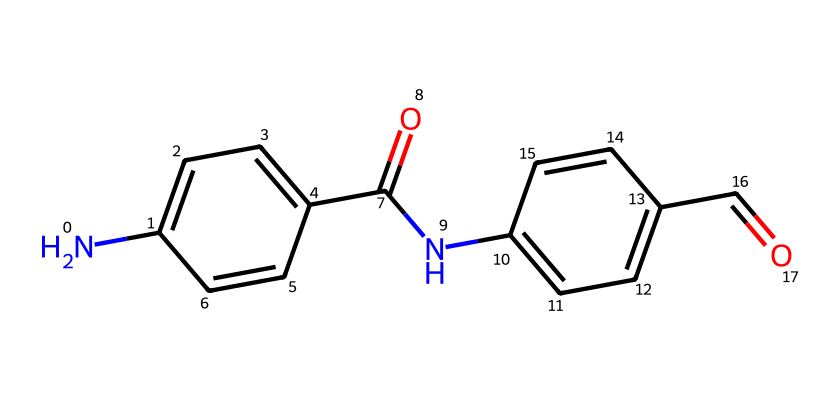What is the molecular formula represented by this SMILES? To determine the molecular formula from the SMILES, first, identify the unique atoms represented. The SMILES contains carbon (C), nitrogen (N), and oxygen (O) atoms. By counting the atoms in the structure, we find there are 14 carbon atoms, 2 nitrogen atoms, and 4 oxygen atoms. Thus, the molecular formula is C14H12N2O4.
Answer: C14H12N2O4 How many nitrogen atoms are present in this molecule? By examining the SMILES structure, we can see that there are two 'N' symbols, which represent nitrogen atoms. Therefore, the total count of nitrogen atoms in this molecule is 2.
Answer: 2 What type of bonding is primarily present in this molecule? The molecule contains single and double bonds, which are characteristic of covalent bonding. The presence of the C=O (carbonyl) groups indicates double bonds, while the C-C and C-N linkages indicate single bonds. Therefore, the primary bonding type in this molecule is covalent.
Answer: covalent What is the role of nitrogen in the structure of Kevlar fibers? Nitrogen atoms in the structure form amide linkages, which contribute to the rigidity and strength of the fibers. The presence of these nitrogen-containing groups is essential for the molecular stability and reinforcing properties of Kevlar.
Answer: amide linkages How many aromatic rings are present in this chemical structure? The structure displays two distinct aromatic ring systems based on the presence of 'c' (carbon in a cyclic structure) in the SMILES. Each of the 'c' sequences corresponds to an aromatic ring, confirming that there are a total of two aromatic rings in the molecule.
Answer: 2 What functional groups are identified in this molecule? The SMILES indicates the presence of amide groups (due to 'C(=O)N') and carbonyl groups (C=O). These functional groups are crucial for the properties of the material. The presence of both groups associates with high tensile strength and thermal stability appropriate for fibers.
Answer: amide and carbonyl groups 